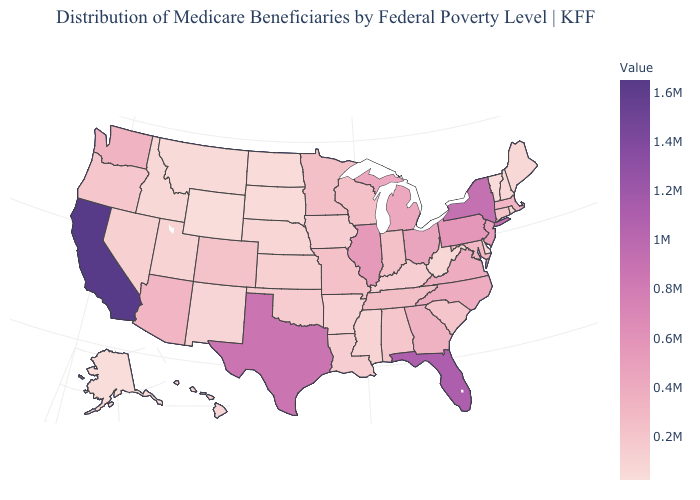Among the states that border Nevada , which have the lowest value?
Give a very brief answer. Idaho. Does Idaho have a lower value than California?
Write a very short answer. Yes. Among the states that border Wyoming , which have the lowest value?
Answer briefly. South Dakota. Does the map have missing data?
Quick response, please. No. Which states hav the highest value in the MidWest?
Answer briefly. Illinois. Does Wyoming have the lowest value in the USA?
Give a very brief answer. Yes. Among the states that border California , does Arizona have the highest value?
Be succinct. Yes. 